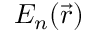Convert formula to latex. <formula><loc_0><loc_0><loc_500><loc_500>{ E } _ { n } ( \ V e c { r } )</formula> 